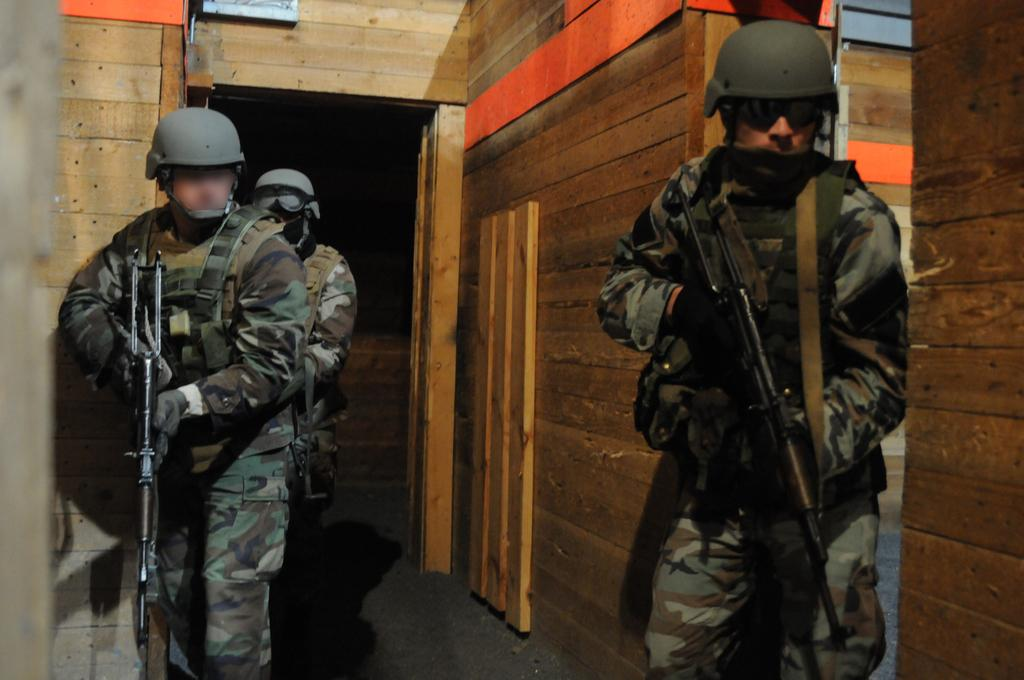Who is present in the image? There are people in the image. What are the people wearing? The people are wearing uniforms. What are the people holding in the image? The people are holding rifles. What can be seen in the background of the image? There is a door in the background of the image. What type of walls are visible in the image? There are wooden walls visible in the image. How many hydrants can be seen in the image? There are no hydrants present in the image. What color is the flame on the uniforms of the people in the image? There are no flames present on the uniforms of the people in the image. 